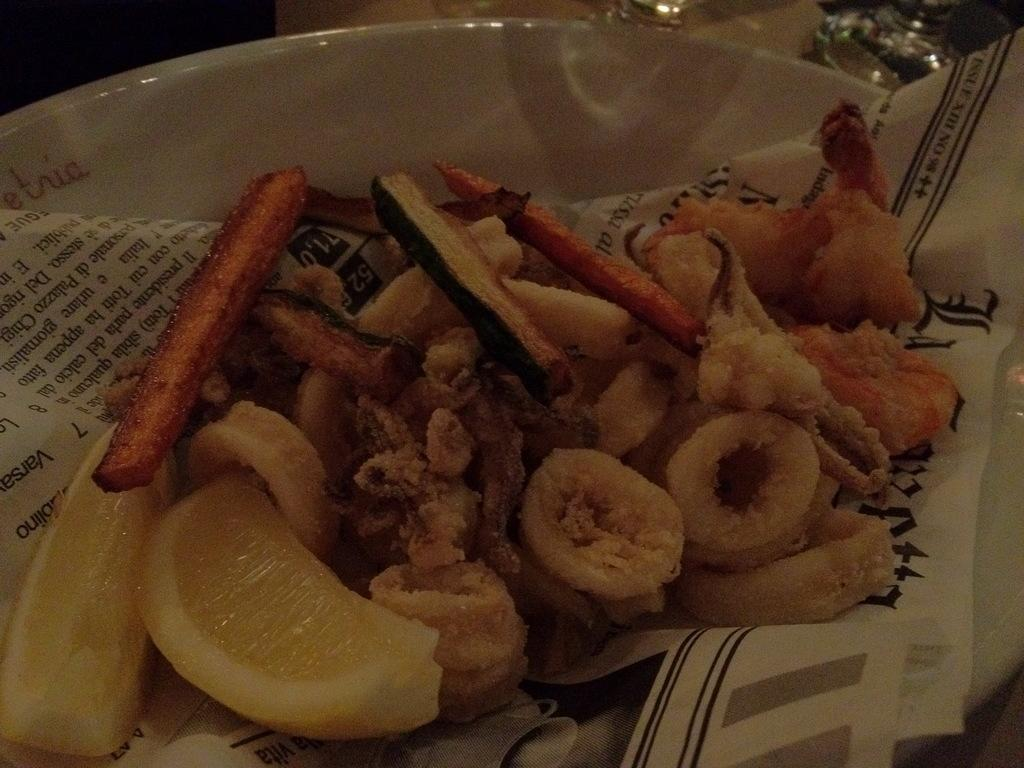What is the primary object in the image? There is a paper in the image. What type of food is in the bowl in the image? There is food in a bowl in the image. What other objects are present beside the bowl in the image? There are other objects beside the bowl in the image. Where is the scarecrow located in the image? There is no scarecrow present in the image. What type of boat can be seen in the image? There is no boat present in the image. 